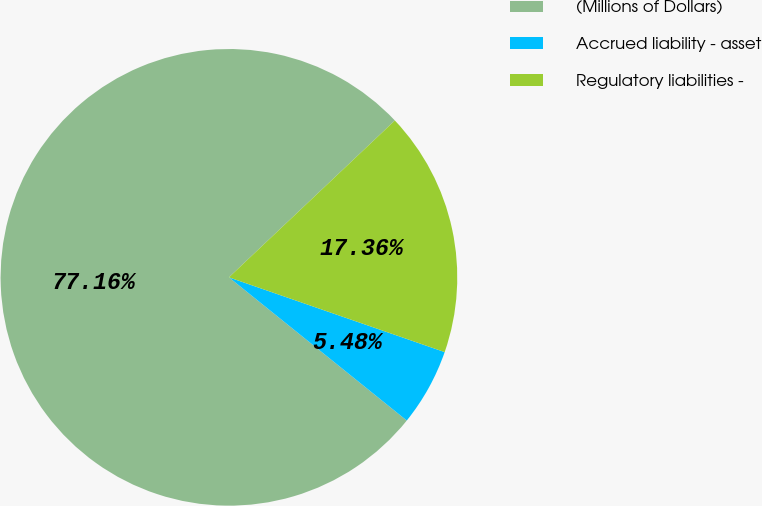Convert chart. <chart><loc_0><loc_0><loc_500><loc_500><pie_chart><fcel>(Millions of Dollars)<fcel>Accrued liability - asset<fcel>Regulatory liabilities -<nl><fcel>77.16%<fcel>5.48%<fcel>17.36%<nl></chart> 